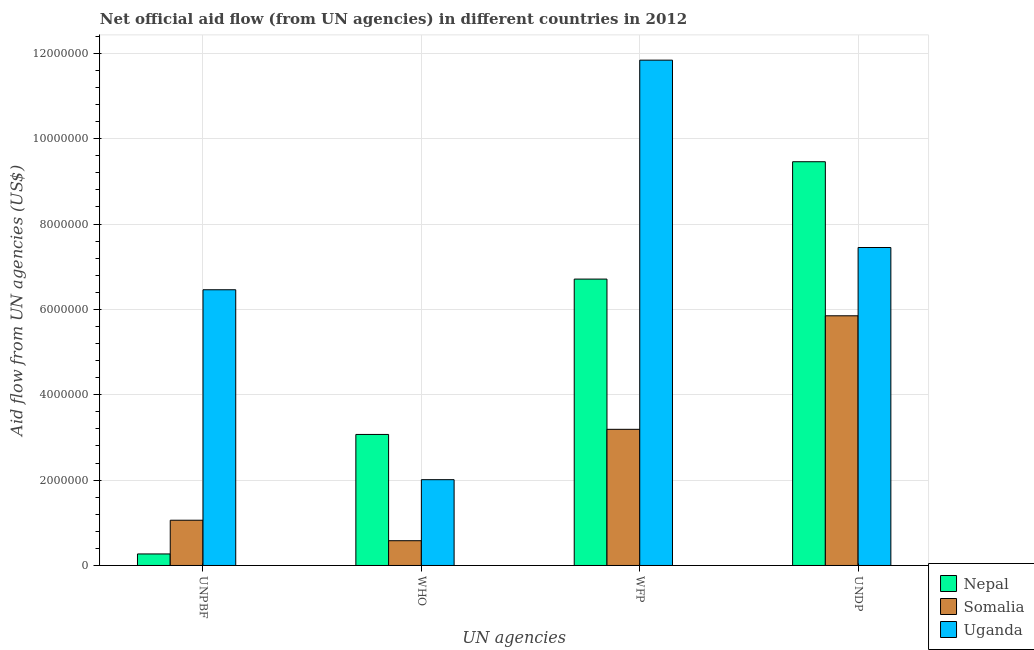Are the number of bars per tick equal to the number of legend labels?
Provide a succinct answer. Yes. Are the number of bars on each tick of the X-axis equal?
Provide a succinct answer. Yes. How many bars are there on the 2nd tick from the left?
Ensure brevity in your answer.  3. How many bars are there on the 2nd tick from the right?
Give a very brief answer. 3. What is the label of the 4th group of bars from the left?
Provide a short and direct response. UNDP. What is the amount of aid given by who in Somalia?
Your answer should be very brief. 5.80e+05. Across all countries, what is the maximum amount of aid given by who?
Give a very brief answer. 3.07e+06. Across all countries, what is the minimum amount of aid given by who?
Offer a very short reply. 5.80e+05. In which country was the amount of aid given by wfp maximum?
Your answer should be very brief. Uganda. In which country was the amount of aid given by unpbf minimum?
Your answer should be compact. Nepal. What is the total amount of aid given by unpbf in the graph?
Your answer should be compact. 7.79e+06. What is the difference between the amount of aid given by who in Uganda and that in Nepal?
Ensure brevity in your answer.  -1.06e+06. What is the difference between the amount of aid given by wfp in Nepal and the amount of aid given by unpbf in Uganda?
Provide a succinct answer. 2.50e+05. What is the average amount of aid given by undp per country?
Your answer should be very brief. 7.59e+06. What is the difference between the amount of aid given by who and amount of aid given by undp in Uganda?
Your response must be concise. -5.44e+06. What is the ratio of the amount of aid given by who in Somalia to that in Uganda?
Give a very brief answer. 0.29. Is the difference between the amount of aid given by undp in Uganda and Somalia greater than the difference between the amount of aid given by who in Uganda and Somalia?
Your answer should be compact. Yes. What is the difference between the highest and the second highest amount of aid given by wfp?
Your answer should be compact. 5.13e+06. What is the difference between the highest and the lowest amount of aid given by wfp?
Provide a succinct answer. 8.65e+06. Is the sum of the amount of aid given by wfp in Somalia and Nepal greater than the maximum amount of aid given by undp across all countries?
Your answer should be compact. Yes. What does the 2nd bar from the left in WFP represents?
Offer a terse response. Somalia. What does the 3rd bar from the right in UNDP represents?
Your response must be concise. Nepal. Is it the case that in every country, the sum of the amount of aid given by unpbf and amount of aid given by who is greater than the amount of aid given by wfp?
Ensure brevity in your answer.  No. How many bars are there?
Provide a succinct answer. 12. Are all the bars in the graph horizontal?
Offer a terse response. No. How many countries are there in the graph?
Provide a short and direct response. 3. Does the graph contain any zero values?
Give a very brief answer. No. Does the graph contain grids?
Give a very brief answer. Yes. How many legend labels are there?
Provide a succinct answer. 3. How are the legend labels stacked?
Ensure brevity in your answer.  Vertical. What is the title of the graph?
Offer a very short reply. Net official aid flow (from UN agencies) in different countries in 2012. What is the label or title of the X-axis?
Provide a short and direct response. UN agencies. What is the label or title of the Y-axis?
Your response must be concise. Aid flow from UN agencies (US$). What is the Aid flow from UN agencies (US$) of Nepal in UNPBF?
Keep it short and to the point. 2.70e+05. What is the Aid flow from UN agencies (US$) of Somalia in UNPBF?
Provide a succinct answer. 1.06e+06. What is the Aid flow from UN agencies (US$) of Uganda in UNPBF?
Make the answer very short. 6.46e+06. What is the Aid flow from UN agencies (US$) in Nepal in WHO?
Offer a terse response. 3.07e+06. What is the Aid flow from UN agencies (US$) in Somalia in WHO?
Your answer should be very brief. 5.80e+05. What is the Aid flow from UN agencies (US$) of Uganda in WHO?
Provide a succinct answer. 2.01e+06. What is the Aid flow from UN agencies (US$) of Nepal in WFP?
Your answer should be very brief. 6.71e+06. What is the Aid flow from UN agencies (US$) in Somalia in WFP?
Make the answer very short. 3.19e+06. What is the Aid flow from UN agencies (US$) in Uganda in WFP?
Your answer should be compact. 1.18e+07. What is the Aid flow from UN agencies (US$) in Nepal in UNDP?
Offer a terse response. 9.46e+06. What is the Aid flow from UN agencies (US$) of Somalia in UNDP?
Give a very brief answer. 5.85e+06. What is the Aid flow from UN agencies (US$) in Uganda in UNDP?
Give a very brief answer. 7.45e+06. Across all UN agencies, what is the maximum Aid flow from UN agencies (US$) in Nepal?
Provide a succinct answer. 9.46e+06. Across all UN agencies, what is the maximum Aid flow from UN agencies (US$) of Somalia?
Keep it short and to the point. 5.85e+06. Across all UN agencies, what is the maximum Aid flow from UN agencies (US$) in Uganda?
Keep it short and to the point. 1.18e+07. Across all UN agencies, what is the minimum Aid flow from UN agencies (US$) in Nepal?
Your answer should be compact. 2.70e+05. Across all UN agencies, what is the minimum Aid flow from UN agencies (US$) in Somalia?
Offer a terse response. 5.80e+05. Across all UN agencies, what is the minimum Aid flow from UN agencies (US$) in Uganda?
Provide a succinct answer. 2.01e+06. What is the total Aid flow from UN agencies (US$) of Nepal in the graph?
Provide a short and direct response. 1.95e+07. What is the total Aid flow from UN agencies (US$) of Somalia in the graph?
Your response must be concise. 1.07e+07. What is the total Aid flow from UN agencies (US$) in Uganda in the graph?
Offer a terse response. 2.78e+07. What is the difference between the Aid flow from UN agencies (US$) of Nepal in UNPBF and that in WHO?
Your answer should be compact. -2.80e+06. What is the difference between the Aid flow from UN agencies (US$) in Somalia in UNPBF and that in WHO?
Provide a succinct answer. 4.80e+05. What is the difference between the Aid flow from UN agencies (US$) of Uganda in UNPBF and that in WHO?
Provide a short and direct response. 4.45e+06. What is the difference between the Aid flow from UN agencies (US$) in Nepal in UNPBF and that in WFP?
Provide a short and direct response. -6.44e+06. What is the difference between the Aid flow from UN agencies (US$) in Somalia in UNPBF and that in WFP?
Make the answer very short. -2.13e+06. What is the difference between the Aid flow from UN agencies (US$) of Uganda in UNPBF and that in WFP?
Your answer should be very brief. -5.38e+06. What is the difference between the Aid flow from UN agencies (US$) in Nepal in UNPBF and that in UNDP?
Make the answer very short. -9.19e+06. What is the difference between the Aid flow from UN agencies (US$) of Somalia in UNPBF and that in UNDP?
Your answer should be compact. -4.79e+06. What is the difference between the Aid flow from UN agencies (US$) in Uganda in UNPBF and that in UNDP?
Your answer should be very brief. -9.90e+05. What is the difference between the Aid flow from UN agencies (US$) in Nepal in WHO and that in WFP?
Give a very brief answer. -3.64e+06. What is the difference between the Aid flow from UN agencies (US$) of Somalia in WHO and that in WFP?
Provide a succinct answer. -2.61e+06. What is the difference between the Aid flow from UN agencies (US$) in Uganda in WHO and that in WFP?
Your answer should be very brief. -9.83e+06. What is the difference between the Aid flow from UN agencies (US$) of Nepal in WHO and that in UNDP?
Offer a very short reply. -6.39e+06. What is the difference between the Aid flow from UN agencies (US$) in Somalia in WHO and that in UNDP?
Keep it short and to the point. -5.27e+06. What is the difference between the Aid flow from UN agencies (US$) of Uganda in WHO and that in UNDP?
Provide a short and direct response. -5.44e+06. What is the difference between the Aid flow from UN agencies (US$) in Nepal in WFP and that in UNDP?
Your answer should be compact. -2.75e+06. What is the difference between the Aid flow from UN agencies (US$) in Somalia in WFP and that in UNDP?
Provide a succinct answer. -2.66e+06. What is the difference between the Aid flow from UN agencies (US$) of Uganda in WFP and that in UNDP?
Keep it short and to the point. 4.39e+06. What is the difference between the Aid flow from UN agencies (US$) in Nepal in UNPBF and the Aid flow from UN agencies (US$) in Somalia in WHO?
Ensure brevity in your answer.  -3.10e+05. What is the difference between the Aid flow from UN agencies (US$) of Nepal in UNPBF and the Aid flow from UN agencies (US$) of Uganda in WHO?
Your answer should be very brief. -1.74e+06. What is the difference between the Aid flow from UN agencies (US$) of Somalia in UNPBF and the Aid flow from UN agencies (US$) of Uganda in WHO?
Give a very brief answer. -9.50e+05. What is the difference between the Aid flow from UN agencies (US$) of Nepal in UNPBF and the Aid flow from UN agencies (US$) of Somalia in WFP?
Keep it short and to the point. -2.92e+06. What is the difference between the Aid flow from UN agencies (US$) of Nepal in UNPBF and the Aid flow from UN agencies (US$) of Uganda in WFP?
Keep it short and to the point. -1.16e+07. What is the difference between the Aid flow from UN agencies (US$) in Somalia in UNPBF and the Aid flow from UN agencies (US$) in Uganda in WFP?
Keep it short and to the point. -1.08e+07. What is the difference between the Aid flow from UN agencies (US$) of Nepal in UNPBF and the Aid flow from UN agencies (US$) of Somalia in UNDP?
Provide a short and direct response. -5.58e+06. What is the difference between the Aid flow from UN agencies (US$) in Nepal in UNPBF and the Aid flow from UN agencies (US$) in Uganda in UNDP?
Provide a short and direct response. -7.18e+06. What is the difference between the Aid flow from UN agencies (US$) in Somalia in UNPBF and the Aid flow from UN agencies (US$) in Uganda in UNDP?
Offer a very short reply. -6.39e+06. What is the difference between the Aid flow from UN agencies (US$) of Nepal in WHO and the Aid flow from UN agencies (US$) of Uganda in WFP?
Your response must be concise. -8.77e+06. What is the difference between the Aid flow from UN agencies (US$) of Somalia in WHO and the Aid flow from UN agencies (US$) of Uganda in WFP?
Offer a very short reply. -1.13e+07. What is the difference between the Aid flow from UN agencies (US$) in Nepal in WHO and the Aid flow from UN agencies (US$) in Somalia in UNDP?
Make the answer very short. -2.78e+06. What is the difference between the Aid flow from UN agencies (US$) in Nepal in WHO and the Aid flow from UN agencies (US$) in Uganda in UNDP?
Give a very brief answer. -4.38e+06. What is the difference between the Aid flow from UN agencies (US$) of Somalia in WHO and the Aid flow from UN agencies (US$) of Uganda in UNDP?
Offer a terse response. -6.87e+06. What is the difference between the Aid flow from UN agencies (US$) in Nepal in WFP and the Aid flow from UN agencies (US$) in Somalia in UNDP?
Provide a short and direct response. 8.60e+05. What is the difference between the Aid flow from UN agencies (US$) of Nepal in WFP and the Aid flow from UN agencies (US$) of Uganda in UNDP?
Keep it short and to the point. -7.40e+05. What is the difference between the Aid flow from UN agencies (US$) of Somalia in WFP and the Aid flow from UN agencies (US$) of Uganda in UNDP?
Offer a very short reply. -4.26e+06. What is the average Aid flow from UN agencies (US$) of Nepal per UN agencies?
Give a very brief answer. 4.88e+06. What is the average Aid flow from UN agencies (US$) in Somalia per UN agencies?
Your answer should be compact. 2.67e+06. What is the average Aid flow from UN agencies (US$) of Uganda per UN agencies?
Your answer should be very brief. 6.94e+06. What is the difference between the Aid flow from UN agencies (US$) of Nepal and Aid flow from UN agencies (US$) of Somalia in UNPBF?
Provide a succinct answer. -7.90e+05. What is the difference between the Aid flow from UN agencies (US$) of Nepal and Aid flow from UN agencies (US$) of Uganda in UNPBF?
Offer a very short reply. -6.19e+06. What is the difference between the Aid flow from UN agencies (US$) in Somalia and Aid flow from UN agencies (US$) in Uganda in UNPBF?
Your response must be concise. -5.40e+06. What is the difference between the Aid flow from UN agencies (US$) in Nepal and Aid flow from UN agencies (US$) in Somalia in WHO?
Provide a succinct answer. 2.49e+06. What is the difference between the Aid flow from UN agencies (US$) of Nepal and Aid flow from UN agencies (US$) of Uganda in WHO?
Give a very brief answer. 1.06e+06. What is the difference between the Aid flow from UN agencies (US$) in Somalia and Aid flow from UN agencies (US$) in Uganda in WHO?
Your answer should be very brief. -1.43e+06. What is the difference between the Aid flow from UN agencies (US$) of Nepal and Aid flow from UN agencies (US$) of Somalia in WFP?
Provide a short and direct response. 3.52e+06. What is the difference between the Aid flow from UN agencies (US$) in Nepal and Aid flow from UN agencies (US$) in Uganda in WFP?
Your answer should be very brief. -5.13e+06. What is the difference between the Aid flow from UN agencies (US$) in Somalia and Aid flow from UN agencies (US$) in Uganda in WFP?
Your response must be concise. -8.65e+06. What is the difference between the Aid flow from UN agencies (US$) in Nepal and Aid flow from UN agencies (US$) in Somalia in UNDP?
Provide a short and direct response. 3.61e+06. What is the difference between the Aid flow from UN agencies (US$) in Nepal and Aid flow from UN agencies (US$) in Uganda in UNDP?
Offer a terse response. 2.01e+06. What is the difference between the Aid flow from UN agencies (US$) in Somalia and Aid flow from UN agencies (US$) in Uganda in UNDP?
Your answer should be very brief. -1.60e+06. What is the ratio of the Aid flow from UN agencies (US$) in Nepal in UNPBF to that in WHO?
Your answer should be very brief. 0.09. What is the ratio of the Aid flow from UN agencies (US$) in Somalia in UNPBF to that in WHO?
Provide a succinct answer. 1.83. What is the ratio of the Aid flow from UN agencies (US$) of Uganda in UNPBF to that in WHO?
Provide a short and direct response. 3.21. What is the ratio of the Aid flow from UN agencies (US$) in Nepal in UNPBF to that in WFP?
Offer a terse response. 0.04. What is the ratio of the Aid flow from UN agencies (US$) in Somalia in UNPBF to that in WFP?
Offer a terse response. 0.33. What is the ratio of the Aid flow from UN agencies (US$) in Uganda in UNPBF to that in WFP?
Provide a succinct answer. 0.55. What is the ratio of the Aid flow from UN agencies (US$) of Nepal in UNPBF to that in UNDP?
Offer a very short reply. 0.03. What is the ratio of the Aid flow from UN agencies (US$) in Somalia in UNPBF to that in UNDP?
Provide a short and direct response. 0.18. What is the ratio of the Aid flow from UN agencies (US$) in Uganda in UNPBF to that in UNDP?
Provide a succinct answer. 0.87. What is the ratio of the Aid flow from UN agencies (US$) of Nepal in WHO to that in WFP?
Your answer should be compact. 0.46. What is the ratio of the Aid flow from UN agencies (US$) of Somalia in WHO to that in WFP?
Your response must be concise. 0.18. What is the ratio of the Aid flow from UN agencies (US$) in Uganda in WHO to that in WFP?
Offer a very short reply. 0.17. What is the ratio of the Aid flow from UN agencies (US$) of Nepal in WHO to that in UNDP?
Keep it short and to the point. 0.32. What is the ratio of the Aid flow from UN agencies (US$) in Somalia in WHO to that in UNDP?
Provide a short and direct response. 0.1. What is the ratio of the Aid flow from UN agencies (US$) of Uganda in WHO to that in UNDP?
Your response must be concise. 0.27. What is the ratio of the Aid flow from UN agencies (US$) in Nepal in WFP to that in UNDP?
Offer a terse response. 0.71. What is the ratio of the Aid flow from UN agencies (US$) of Somalia in WFP to that in UNDP?
Give a very brief answer. 0.55. What is the ratio of the Aid flow from UN agencies (US$) of Uganda in WFP to that in UNDP?
Make the answer very short. 1.59. What is the difference between the highest and the second highest Aid flow from UN agencies (US$) of Nepal?
Make the answer very short. 2.75e+06. What is the difference between the highest and the second highest Aid flow from UN agencies (US$) of Somalia?
Give a very brief answer. 2.66e+06. What is the difference between the highest and the second highest Aid flow from UN agencies (US$) in Uganda?
Offer a very short reply. 4.39e+06. What is the difference between the highest and the lowest Aid flow from UN agencies (US$) of Nepal?
Provide a short and direct response. 9.19e+06. What is the difference between the highest and the lowest Aid flow from UN agencies (US$) of Somalia?
Keep it short and to the point. 5.27e+06. What is the difference between the highest and the lowest Aid flow from UN agencies (US$) in Uganda?
Make the answer very short. 9.83e+06. 